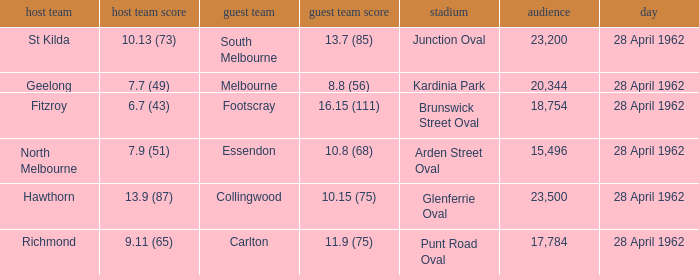What away team played at Brunswick Street Oval? Footscray. 